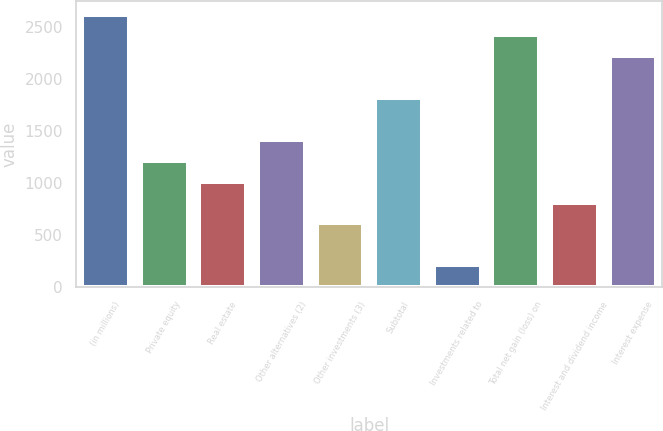Convert chart. <chart><loc_0><loc_0><loc_500><loc_500><bar_chart><fcel>(in millions)<fcel>Private equity<fcel>Real estate<fcel>Other alternatives (2)<fcel>Other investments (3)<fcel>Subtotal<fcel>Investments related to<fcel>Total net gain (loss) on<fcel>Interest and dividend income<fcel>Interest expense<nl><fcel>2614.8<fcel>1210.6<fcel>1010<fcel>1411.2<fcel>608.8<fcel>1812.4<fcel>207.6<fcel>2414.2<fcel>809.4<fcel>2213.6<nl></chart> 